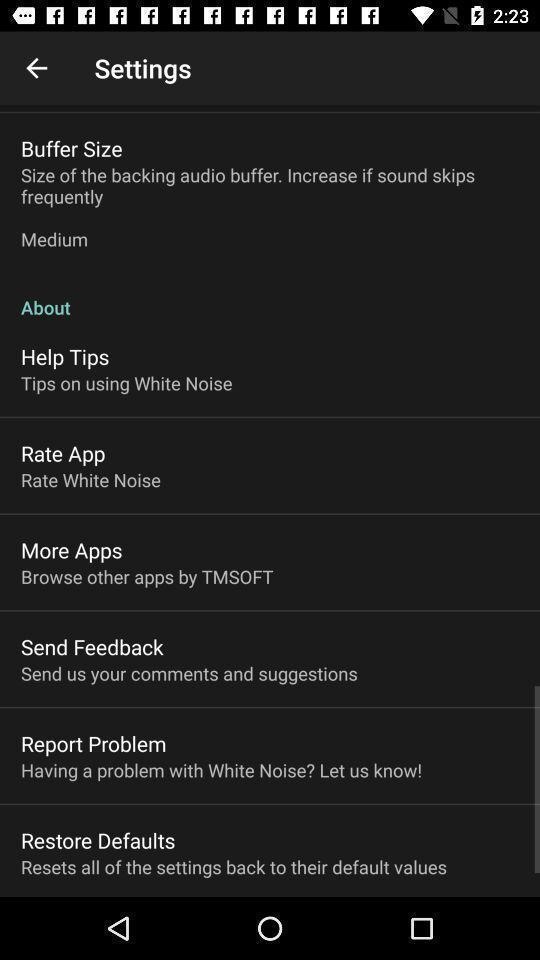Describe the key features of this screenshot. Screen shows settings. 